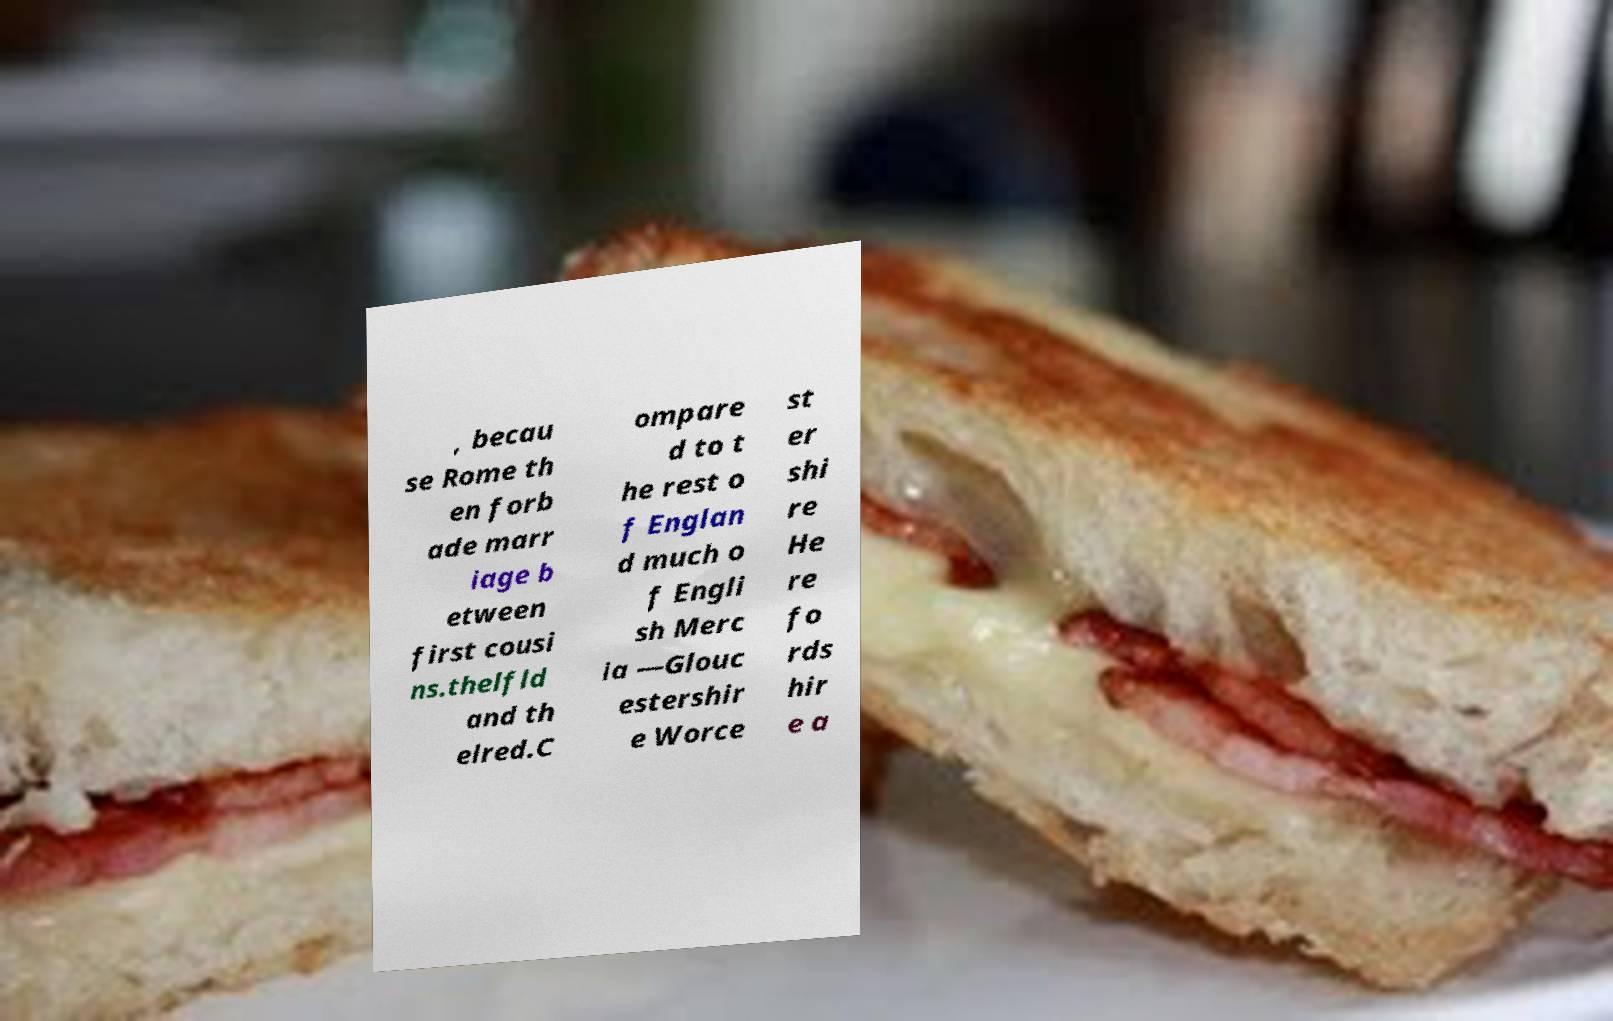Please identify and transcribe the text found in this image. , becau se Rome th en forb ade marr iage b etween first cousi ns.thelfld and th elred.C ompare d to t he rest o f Englan d much o f Engli sh Merc ia —Glouc estershir e Worce st er shi re He re fo rds hir e a 